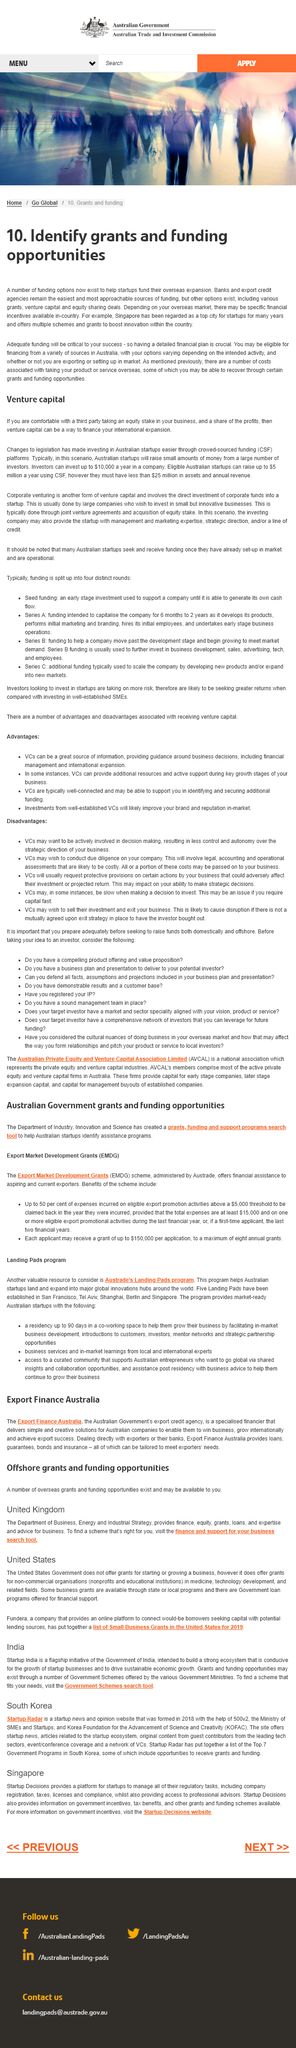Specify some key components in this picture. Having a detailed financial plan is crucial to the success of identifying grants and funding opportunities. The Department of Business provides expertise and advice for businesses. The acronym "CSF" stands for "Crowd Sourced Funding," which refers to a method of fundraising that involves soliciting small contributions from a large number of people, typically through the internet. The title of this page is "Venture Capital. For many years, Singapore has been regarded as a top city for startups. 